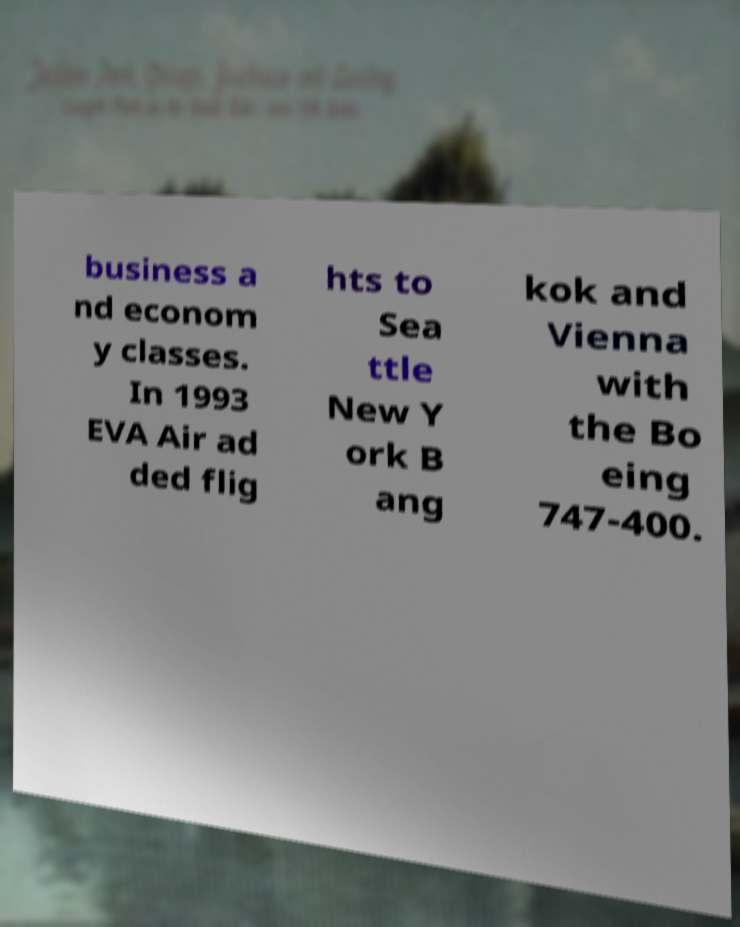Could you extract and type out the text from this image? business a nd econom y classes. In 1993 EVA Air ad ded flig hts to Sea ttle New Y ork B ang kok and Vienna with the Bo eing 747-400. 